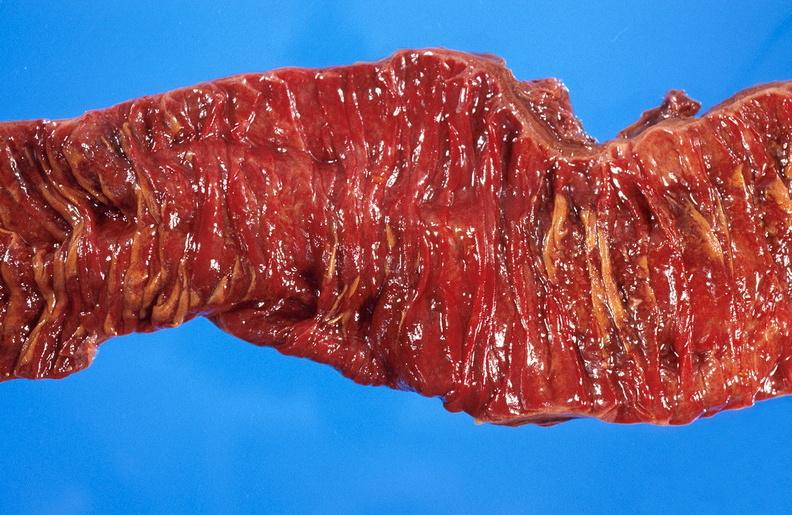what does this image show?
Answer the question using a single word or phrase. Ischemic bowel 